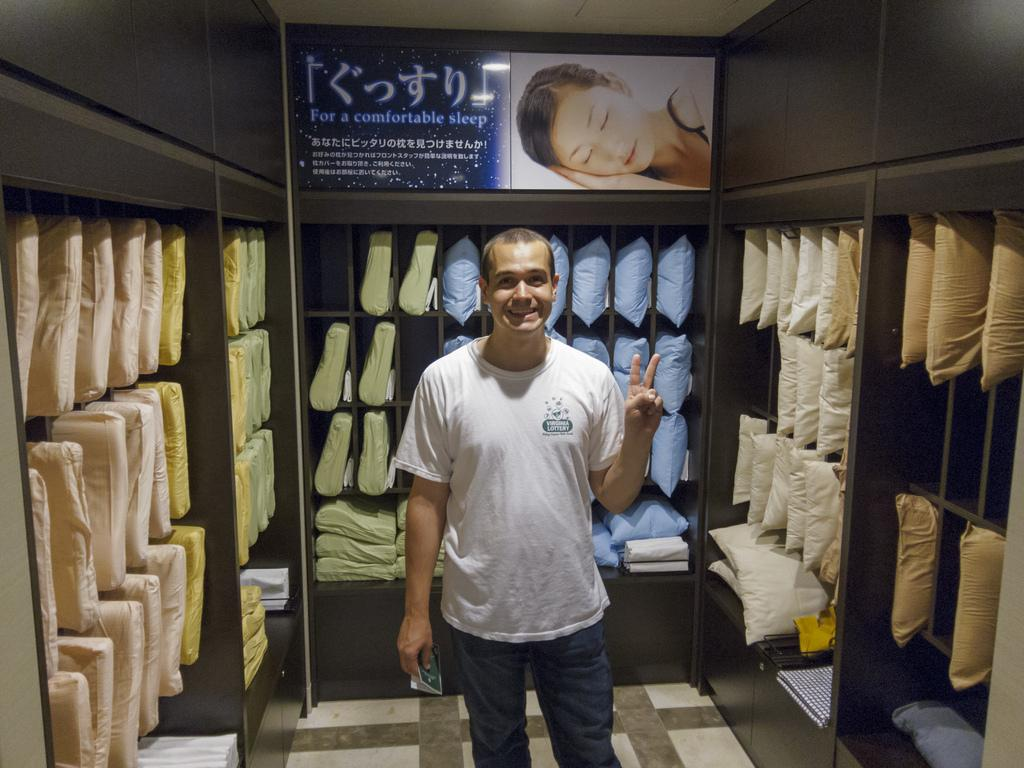What is the main subject of the image? There is a man standing in the image. Where is the man standing? The man is standing on the floor. What can be seen in the cupboards in the image? There are pillows arranged in rows in cupboards. What is visible at the top of the image? There is an advertisement visible at the top of the image. Is the man standing in quicksand in the image? No, the man is standing on the floor, not in quicksand. Can you see a volcano erupting in the image? No, there is no volcano present in the image. 